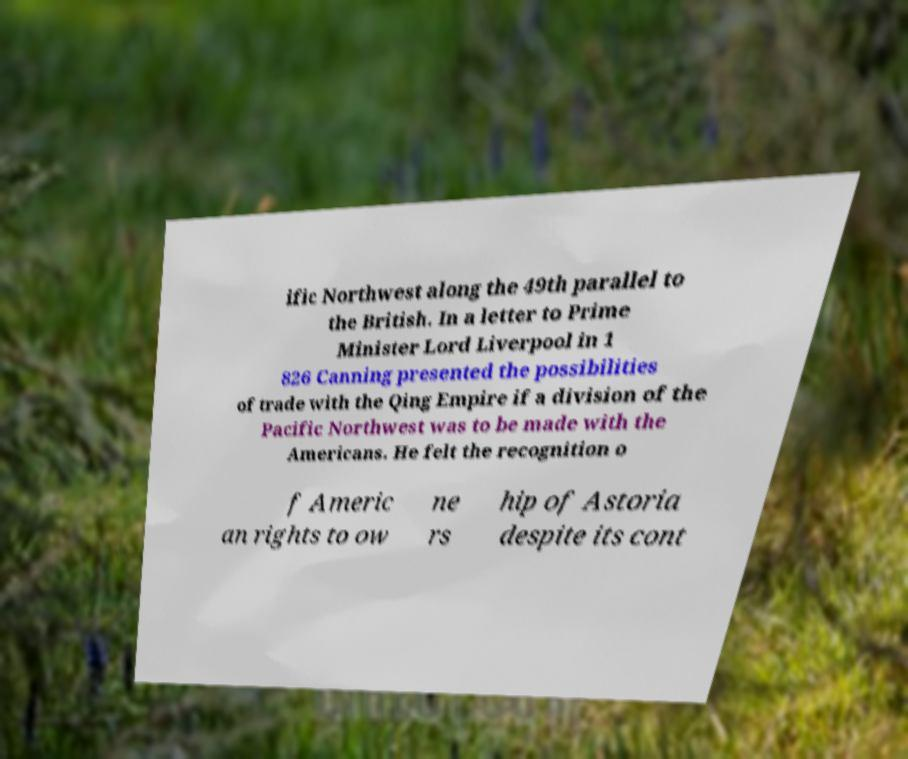Please read and relay the text visible in this image. What does it say? ific Northwest along the 49th parallel to the British. In a letter to Prime Minister Lord Liverpool in 1 826 Canning presented the possibilities of trade with the Qing Empire if a division of the Pacific Northwest was to be made with the Americans. He felt the recognition o f Americ an rights to ow ne rs hip of Astoria despite its cont 